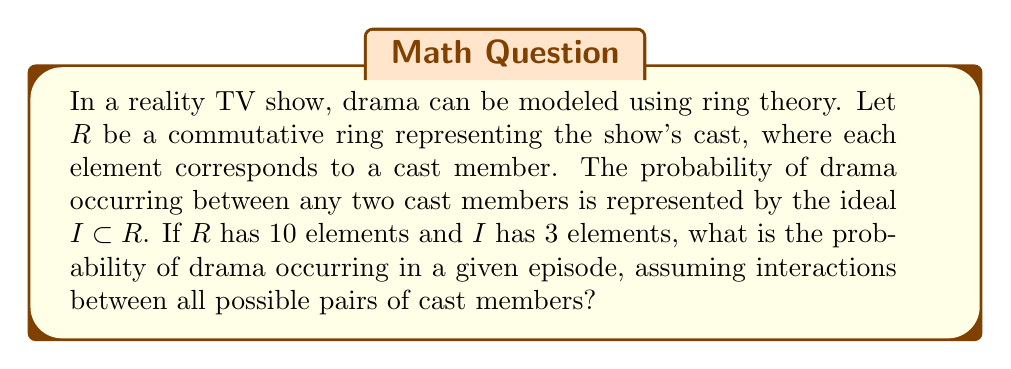Solve this math problem. To solve this problem, we need to apply concepts from ring theory and probability:

1) In ring theory, an ideal $I$ of a ring $R$ is a subset of $R$ that satisfies certain properties. In this context, the elements of $I$ represent the combinations of cast members that create drama.

2) The total number of possible interactions (pairs) between cast members is given by the combination formula:

   $$\binom{10}{2} = \frac{10!}{2!(10-2)!} = 45$$

3) The number of drama-causing interactions is represented by the number of elements in the ideal $I$, which is 3.

4) The probability of drama occurring is the ratio of favorable outcomes to total possible outcomes:

   $$P(\text{drama}) = \frac{\text{number of drama-causing interactions}}{\text{total number of possible interactions}}$$

5) Substituting the values:

   $$P(\text{drama}) = \frac{3}{45} = \frac{1}{15} \approx 0.0667$$

6) Therefore, the probability of drama occurring in a given episode is $\frac{1}{15}$ or approximately 6.67%.
Answer: The probability of drama occurring in a given episode is $\frac{1}{15}$ or approximately 6.67%. 